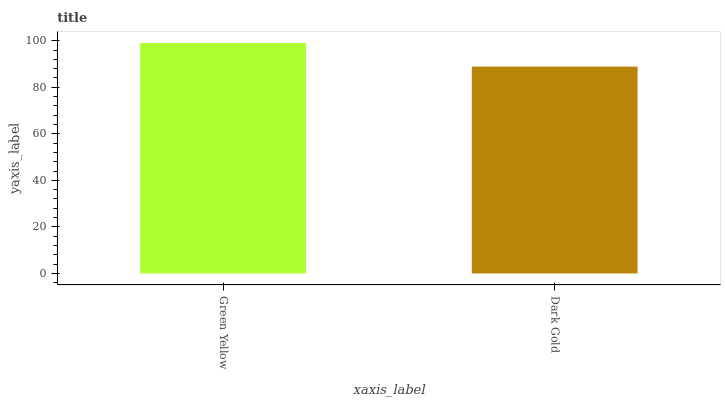Is Dark Gold the minimum?
Answer yes or no. Yes. Is Green Yellow the maximum?
Answer yes or no. Yes. Is Dark Gold the maximum?
Answer yes or no. No. Is Green Yellow greater than Dark Gold?
Answer yes or no. Yes. Is Dark Gold less than Green Yellow?
Answer yes or no. Yes. Is Dark Gold greater than Green Yellow?
Answer yes or no. No. Is Green Yellow less than Dark Gold?
Answer yes or no. No. Is Green Yellow the high median?
Answer yes or no. Yes. Is Dark Gold the low median?
Answer yes or no. Yes. Is Dark Gold the high median?
Answer yes or no. No. Is Green Yellow the low median?
Answer yes or no. No. 